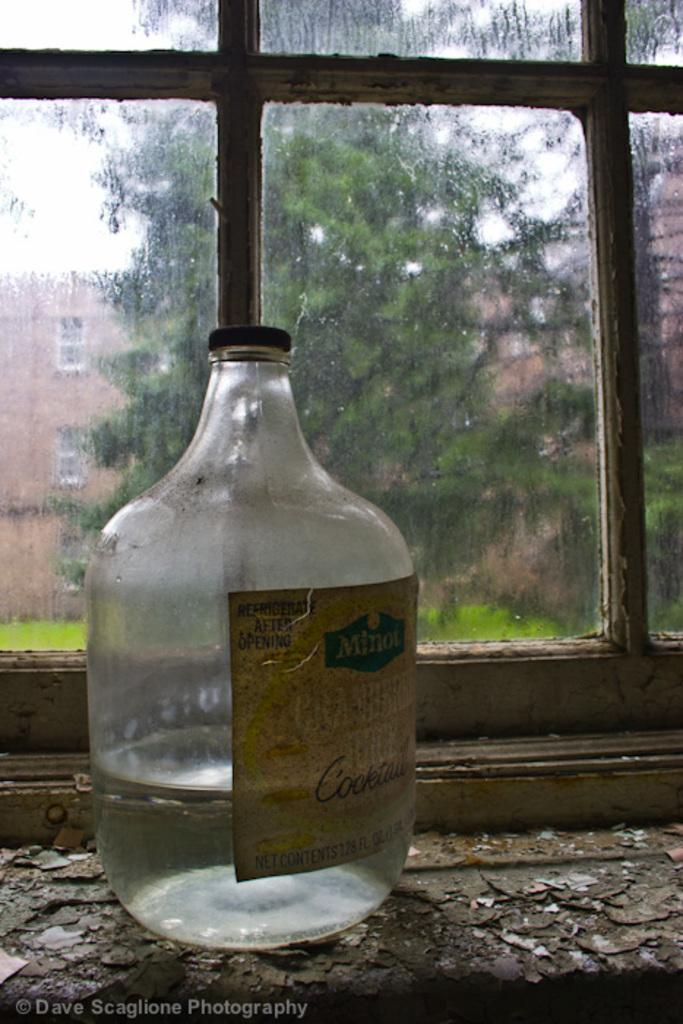What object can be seen in the image that is typically used for holding liquids? There is a glass bottle in the image. What architectural feature is present in the image? There is a window in the image. What can be seen through the window in the image? Trees and buildings are visible outside the window. What type of doll is sitting on the calendar in the image? There is no doll or calendar present in the image. 